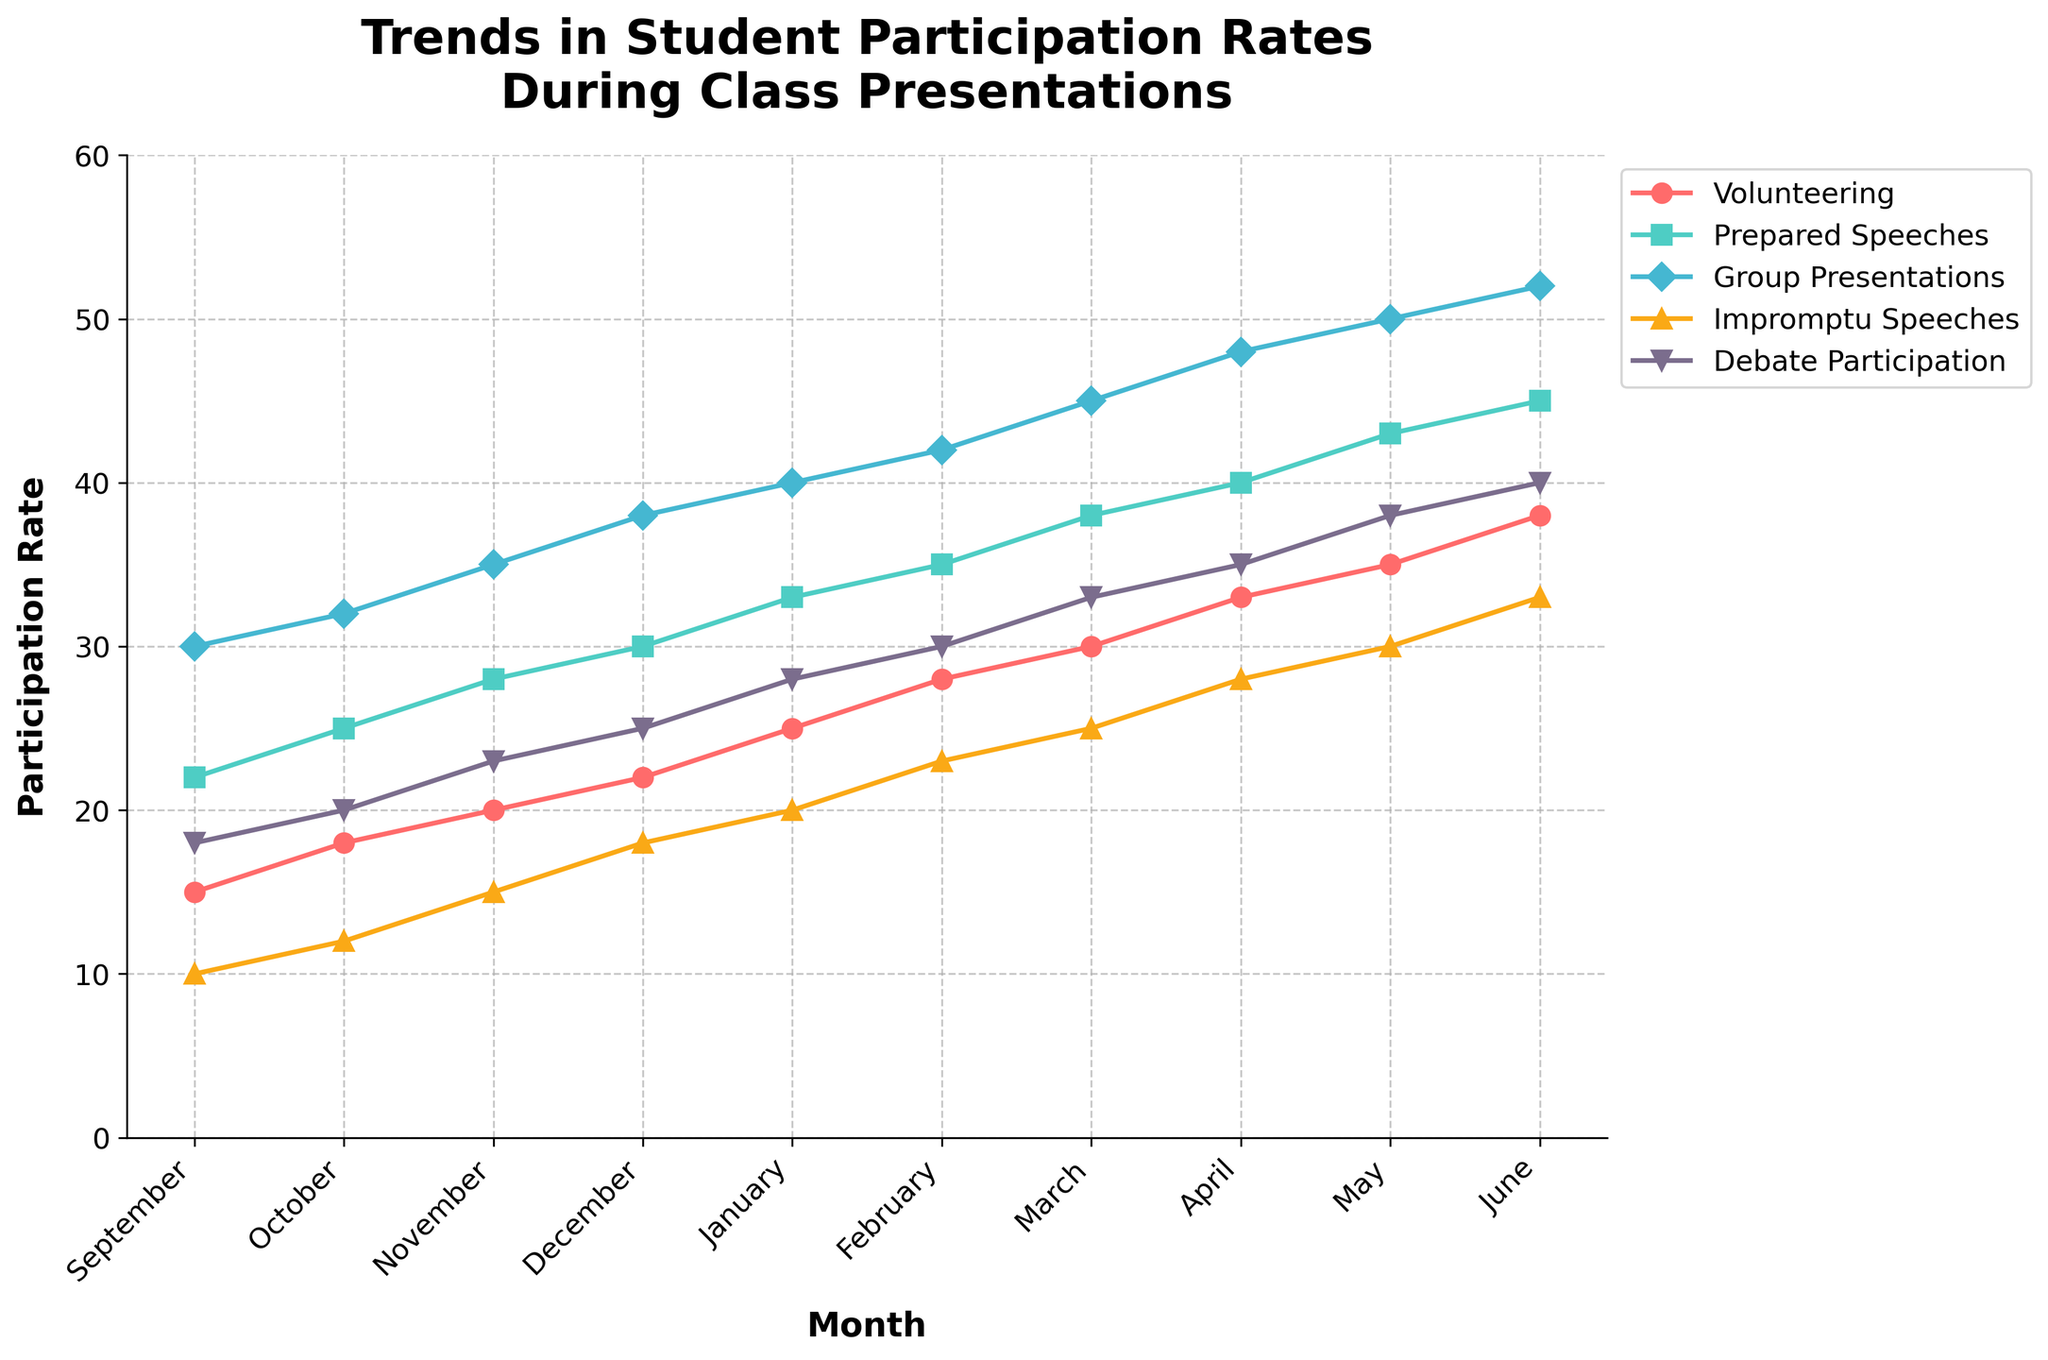What month has the highest participation rate in Volunteering? In the figure, follow the red line representing Volunteering. The highest point on this line corresponds to June.
Answer: June Which category shows the most significant increase in participation from September to June? Examine the slopes of the lines between September and June. The Impromptu Speeches line (green) shows a significant increase, from 10 to 33.
Answer: Impromptu Speeches During what month do Group Presentations surpass Prepared Speeches? Follow the blue line for Group Presentations and the teal line for Prepared Speeches. Group Presentations surpass Prepared Speeches in November.
Answer: November How much does Debate Participation increase from December to February? Find the yellow line representing Debate Participation. In December, it's 25 and rises to 30 in February. The increase is 30 - 25 = 5.
Answer: 5 Calculate the average participation rate for Volunteering across all months. Sum the Volunteering rates from September to June (15 + 18 + 20 + 22 + 25 + 28 + 30 + 33 + 35 + 38) = 264. Average is 264/10 = 26.4.
Answer: 26.4 Which month has the same participation rate for both Group Presentations and Impromptu Speeches? Observe intersections of the blue line (Group Presentations) and green line (Impromptu Speeches). In May, both lines intersect at 30.
Answer: May Compare the participation rates in October for Prepared Speeches and Debate Participation. Which is higher? For October, the teal line for Prepared Speeches is at 25 while the yellow line for Debate Participation is at 20. Prepared Speeches has a higher rate.
Answer: Prepared Speeches What is the total participation rate for all categories in March? Sum the rates in March: Volunteering (30) + Prepared Speeches (38) + Group Presentations (45) + Impromptu Speeches (25) + Debate Participation (33). Total is 30 + 38 + 45 + 25 + 33 = 171.
Answer: 171 How does the participation rate of Impromptu Speeches in January compare to that in April? January is 20 (green line), and April is 28. April's participation is higher by 28 - 20 = 8.
Answer: 8 Which category consistently increases its participation rate each month? Check the trend lines of all categories. Volunteering (red line) consistently increases each month.
Answer: Volunteering 